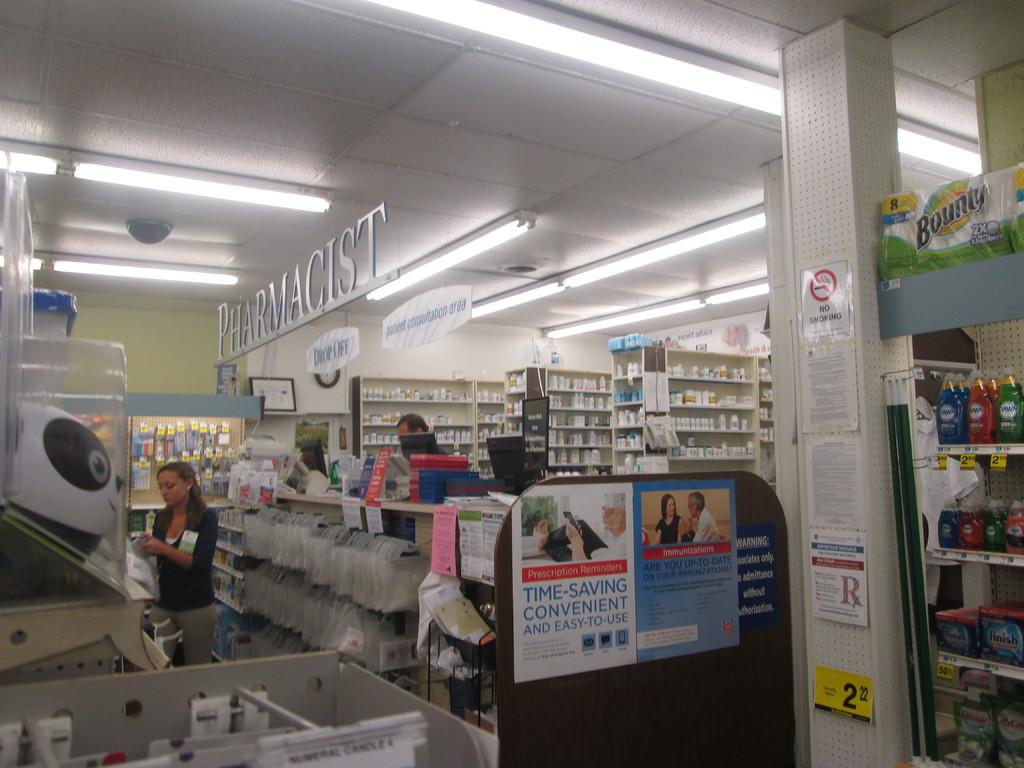Is smoking allowed here?
Your answer should be compact. No. Does the sign mention it being time-saving or convenient?
Your answer should be compact. Yes. 